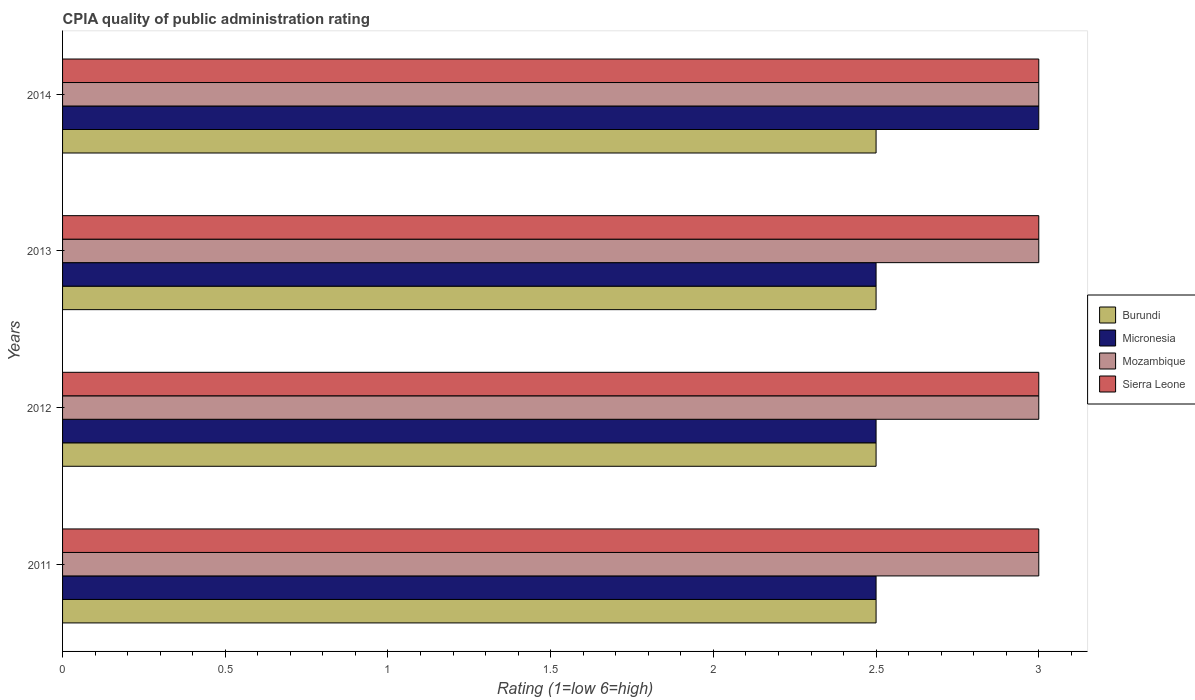How many different coloured bars are there?
Make the answer very short. 4. Are the number of bars on each tick of the Y-axis equal?
Keep it short and to the point. Yes. How many bars are there on the 2nd tick from the bottom?
Give a very brief answer. 4. In which year was the CPIA rating in Burundi minimum?
Make the answer very short. 2011. What is the total CPIA rating in Mozambique in the graph?
Provide a short and direct response. 12. What is the difference between the CPIA rating in Micronesia in 2012 and that in 2014?
Provide a succinct answer. -0.5. What is the difference between the CPIA rating in Mozambique in 2011 and the CPIA rating in Sierra Leone in 2013?
Provide a succinct answer. 0. What is the average CPIA rating in Sierra Leone per year?
Provide a succinct answer. 3. In the year 2013, what is the difference between the CPIA rating in Sierra Leone and CPIA rating in Mozambique?
Offer a very short reply. 0. What is the ratio of the CPIA rating in Sierra Leone in 2012 to that in 2013?
Your answer should be compact. 1. Is the CPIA rating in Sierra Leone in 2011 less than that in 2013?
Make the answer very short. No. What is the difference between the highest and the second highest CPIA rating in Sierra Leone?
Your answer should be compact. 0. What is the difference between the highest and the lowest CPIA rating in Sierra Leone?
Ensure brevity in your answer.  0. Is the sum of the CPIA rating in Micronesia in 2012 and 2014 greater than the maximum CPIA rating in Mozambique across all years?
Keep it short and to the point. Yes. What does the 2nd bar from the top in 2012 represents?
Provide a short and direct response. Mozambique. What does the 4th bar from the bottom in 2011 represents?
Provide a succinct answer. Sierra Leone. Is it the case that in every year, the sum of the CPIA rating in Micronesia and CPIA rating in Burundi is greater than the CPIA rating in Sierra Leone?
Ensure brevity in your answer.  Yes. How many bars are there?
Make the answer very short. 16. Are all the bars in the graph horizontal?
Keep it short and to the point. Yes. What is the difference between two consecutive major ticks on the X-axis?
Keep it short and to the point. 0.5. Are the values on the major ticks of X-axis written in scientific E-notation?
Keep it short and to the point. No. Where does the legend appear in the graph?
Your answer should be compact. Center right. How many legend labels are there?
Offer a terse response. 4. How are the legend labels stacked?
Provide a short and direct response. Vertical. What is the title of the graph?
Ensure brevity in your answer.  CPIA quality of public administration rating. Does "Solomon Islands" appear as one of the legend labels in the graph?
Keep it short and to the point. No. What is the label or title of the X-axis?
Offer a terse response. Rating (1=low 6=high). What is the label or title of the Y-axis?
Give a very brief answer. Years. What is the Rating (1=low 6=high) in Mozambique in 2012?
Offer a very short reply. 3. What is the Rating (1=low 6=high) in Burundi in 2013?
Your answer should be very brief. 2.5. What is the Rating (1=low 6=high) in Micronesia in 2013?
Offer a very short reply. 2.5. What is the Rating (1=low 6=high) of Mozambique in 2013?
Ensure brevity in your answer.  3. What is the Rating (1=low 6=high) of Burundi in 2014?
Your answer should be very brief. 2.5. Across all years, what is the maximum Rating (1=low 6=high) of Burundi?
Your answer should be very brief. 2.5. Across all years, what is the maximum Rating (1=low 6=high) of Micronesia?
Your answer should be very brief. 3. Across all years, what is the maximum Rating (1=low 6=high) of Sierra Leone?
Provide a succinct answer. 3. Across all years, what is the minimum Rating (1=low 6=high) of Burundi?
Offer a very short reply. 2.5. Across all years, what is the minimum Rating (1=low 6=high) in Micronesia?
Keep it short and to the point. 2.5. Across all years, what is the minimum Rating (1=low 6=high) of Mozambique?
Your response must be concise. 3. Across all years, what is the minimum Rating (1=low 6=high) of Sierra Leone?
Provide a succinct answer. 3. What is the total Rating (1=low 6=high) of Sierra Leone in the graph?
Your answer should be very brief. 12. What is the difference between the Rating (1=low 6=high) of Burundi in 2011 and that in 2012?
Give a very brief answer. 0. What is the difference between the Rating (1=low 6=high) of Mozambique in 2011 and that in 2012?
Offer a terse response. 0. What is the difference between the Rating (1=low 6=high) of Mozambique in 2011 and that in 2013?
Offer a very short reply. 0. What is the difference between the Rating (1=low 6=high) of Sierra Leone in 2011 and that in 2013?
Offer a very short reply. 0. What is the difference between the Rating (1=low 6=high) in Micronesia in 2011 and that in 2014?
Your response must be concise. -0.5. What is the difference between the Rating (1=low 6=high) in Sierra Leone in 2011 and that in 2014?
Give a very brief answer. 0. What is the difference between the Rating (1=low 6=high) of Burundi in 2012 and that in 2013?
Provide a succinct answer. 0. What is the difference between the Rating (1=low 6=high) in Mozambique in 2012 and that in 2013?
Your answer should be very brief. 0. What is the difference between the Rating (1=low 6=high) of Burundi in 2012 and that in 2014?
Keep it short and to the point. 0. What is the difference between the Rating (1=low 6=high) of Micronesia in 2012 and that in 2014?
Offer a very short reply. -0.5. What is the difference between the Rating (1=low 6=high) in Burundi in 2013 and that in 2014?
Keep it short and to the point. 0. What is the difference between the Rating (1=low 6=high) of Mozambique in 2013 and that in 2014?
Provide a succinct answer. 0. What is the difference between the Rating (1=low 6=high) of Sierra Leone in 2013 and that in 2014?
Offer a very short reply. 0. What is the difference between the Rating (1=low 6=high) of Burundi in 2011 and the Rating (1=low 6=high) of Sierra Leone in 2012?
Make the answer very short. -0.5. What is the difference between the Rating (1=low 6=high) in Micronesia in 2011 and the Rating (1=low 6=high) in Mozambique in 2012?
Offer a very short reply. -0.5. What is the difference between the Rating (1=low 6=high) in Mozambique in 2011 and the Rating (1=low 6=high) in Sierra Leone in 2012?
Make the answer very short. 0. What is the difference between the Rating (1=low 6=high) in Burundi in 2011 and the Rating (1=low 6=high) in Micronesia in 2013?
Your answer should be compact. 0. What is the difference between the Rating (1=low 6=high) in Burundi in 2011 and the Rating (1=low 6=high) in Micronesia in 2014?
Your response must be concise. -0.5. What is the difference between the Rating (1=low 6=high) in Burundi in 2011 and the Rating (1=low 6=high) in Mozambique in 2014?
Your answer should be very brief. -0.5. What is the difference between the Rating (1=low 6=high) of Mozambique in 2011 and the Rating (1=low 6=high) of Sierra Leone in 2014?
Make the answer very short. 0. What is the difference between the Rating (1=low 6=high) of Burundi in 2012 and the Rating (1=low 6=high) of Micronesia in 2013?
Keep it short and to the point. 0. What is the difference between the Rating (1=low 6=high) in Burundi in 2012 and the Rating (1=low 6=high) in Mozambique in 2013?
Provide a short and direct response. -0.5. What is the difference between the Rating (1=low 6=high) in Micronesia in 2012 and the Rating (1=low 6=high) in Sierra Leone in 2013?
Your response must be concise. -0.5. What is the difference between the Rating (1=low 6=high) of Mozambique in 2012 and the Rating (1=low 6=high) of Sierra Leone in 2013?
Your answer should be very brief. 0. What is the difference between the Rating (1=low 6=high) in Burundi in 2012 and the Rating (1=low 6=high) in Sierra Leone in 2014?
Your answer should be very brief. -0.5. What is the difference between the Rating (1=low 6=high) in Mozambique in 2012 and the Rating (1=low 6=high) in Sierra Leone in 2014?
Keep it short and to the point. 0. What is the difference between the Rating (1=low 6=high) in Burundi in 2013 and the Rating (1=low 6=high) in Micronesia in 2014?
Your response must be concise. -0.5. What is the difference between the Rating (1=low 6=high) in Burundi in 2013 and the Rating (1=low 6=high) in Mozambique in 2014?
Your answer should be compact. -0.5. What is the difference between the Rating (1=low 6=high) in Micronesia in 2013 and the Rating (1=low 6=high) in Mozambique in 2014?
Offer a terse response. -0.5. What is the average Rating (1=low 6=high) in Micronesia per year?
Provide a succinct answer. 2.62. What is the average Rating (1=low 6=high) in Sierra Leone per year?
Make the answer very short. 3. In the year 2011, what is the difference between the Rating (1=low 6=high) of Burundi and Rating (1=low 6=high) of Micronesia?
Give a very brief answer. 0. In the year 2011, what is the difference between the Rating (1=low 6=high) in Burundi and Rating (1=low 6=high) in Mozambique?
Provide a succinct answer. -0.5. In the year 2011, what is the difference between the Rating (1=low 6=high) of Micronesia and Rating (1=low 6=high) of Mozambique?
Offer a very short reply. -0.5. In the year 2012, what is the difference between the Rating (1=low 6=high) of Burundi and Rating (1=low 6=high) of Micronesia?
Ensure brevity in your answer.  0. In the year 2012, what is the difference between the Rating (1=low 6=high) in Micronesia and Rating (1=low 6=high) in Mozambique?
Offer a very short reply. -0.5. In the year 2012, what is the difference between the Rating (1=low 6=high) of Micronesia and Rating (1=low 6=high) of Sierra Leone?
Offer a very short reply. -0.5. In the year 2012, what is the difference between the Rating (1=low 6=high) in Mozambique and Rating (1=low 6=high) in Sierra Leone?
Your answer should be compact. 0. In the year 2013, what is the difference between the Rating (1=low 6=high) of Burundi and Rating (1=low 6=high) of Micronesia?
Your answer should be very brief. 0. In the year 2013, what is the difference between the Rating (1=low 6=high) of Micronesia and Rating (1=low 6=high) of Mozambique?
Ensure brevity in your answer.  -0.5. In the year 2013, what is the difference between the Rating (1=low 6=high) of Micronesia and Rating (1=low 6=high) of Sierra Leone?
Make the answer very short. -0.5. In the year 2013, what is the difference between the Rating (1=low 6=high) of Mozambique and Rating (1=low 6=high) of Sierra Leone?
Provide a succinct answer. 0. In the year 2014, what is the difference between the Rating (1=low 6=high) in Burundi and Rating (1=low 6=high) in Micronesia?
Your answer should be compact. -0.5. In the year 2014, what is the difference between the Rating (1=low 6=high) in Burundi and Rating (1=low 6=high) in Mozambique?
Keep it short and to the point. -0.5. In the year 2014, what is the difference between the Rating (1=low 6=high) of Burundi and Rating (1=low 6=high) of Sierra Leone?
Give a very brief answer. -0.5. In the year 2014, what is the difference between the Rating (1=low 6=high) in Mozambique and Rating (1=low 6=high) in Sierra Leone?
Your answer should be very brief. 0. What is the ratio of the Rating (1=low 6=high) in Micronesia in 2011 to that in 2012?
Provide a succinct answer. 1. What is the ratio of the Rating (1=low 6=high) in Sierra Leone in 2011 to that in 2012?
Your answer should be very brief. 1. What is the ratio of the Rating (1=low 6=high) in Burundi in 2011 to that in 2013?
Your answer should be compact. 1. What is the ratio of the Rating (1=low 6=high) of Micronesia in 2011 to that in 2013?
Offer a terse response. 1. What is the ratio of the Rating (1=low 6=high) in Burundi in 2011 to that in 2014?
Make the answer very short. 1. What is the ratio of the Rating (1=low 6=high) in Micronesia in 2011 to that in 2014?
Offer a terse response. 0.83. What is the ratio of the Rating (1=low 6=high) in Mozambique in 2011 to that in 2014?
Your answer should be very brief. 1. What is the ratio of the Rating (1=low 6=high) in Sierra Leone in 2011 to that in 2014?
Your answer should be compact. 1. What is the ratio of the Rating (1=low 6=high) of Burundi in 2012 to that in 2013?
Provide a succinct answer. 1. What is the ratio of the Rating (1=low 6=high) in Sierra Leone in 2012 to that in 2013?
Your answer should be very brief. 1. What is the ratio of the Rating (1=low 6=high) of Burundi in 2012 to that in 2014?
Your response must be concise. 1. What is the ratio of the Rating (1=low 6=high) of Micronesia in 2012 to that in 2014?
Ensure brevity in your answer.  0.83. What is the ratio of the Rating (1=low 6=high) in Mozambique in 2012 to that in 2014?
Offer a terse response. 1. What is the ratio of the Rating (1=low 6=high) in Sierra Leone in 2012 to that in 2014?
Your answer should be very brief. 1. What is the ratio of the Rating (1=low 6=high) of Burundi in 2013 to that in 2014?
Give a very brief answer. 1. What is the difference between the highest and the second highest Rating (1=low 6=high) in Mozambique?
Provide a short and direct response. 0. What is the difference between the highest and the second highest Rating (1=low 6=high) of Sierra Leone?
Your answer should be very brief. 0. 